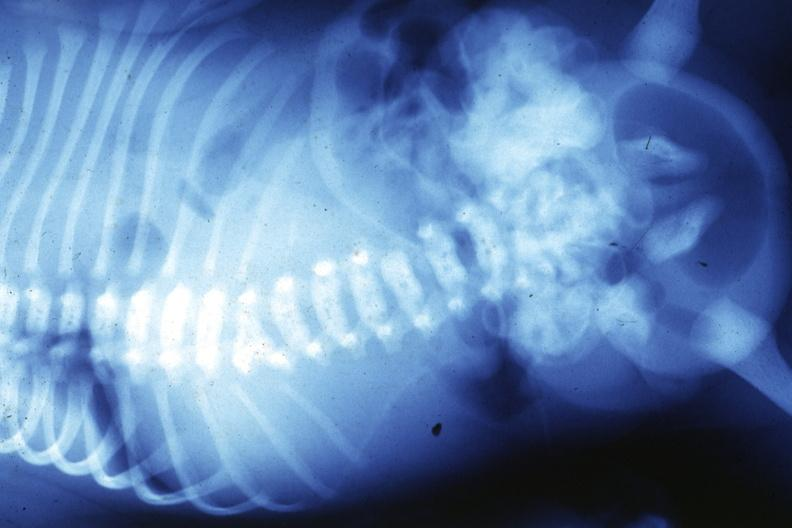does this image show x-ray infant t12 lesion?
Answer the question using a single word or phrase. Yes 